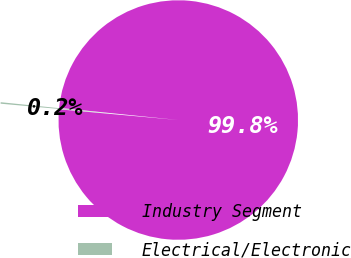Convert chart to OTSL. <chart><loc_0><loc_0><loc_500><loc_500><pie_chart><fcel>Industry Segment<fcel>Electrical/Electronic<nl><fcel>99.8%<fcel>0.2%<nl></chart> 